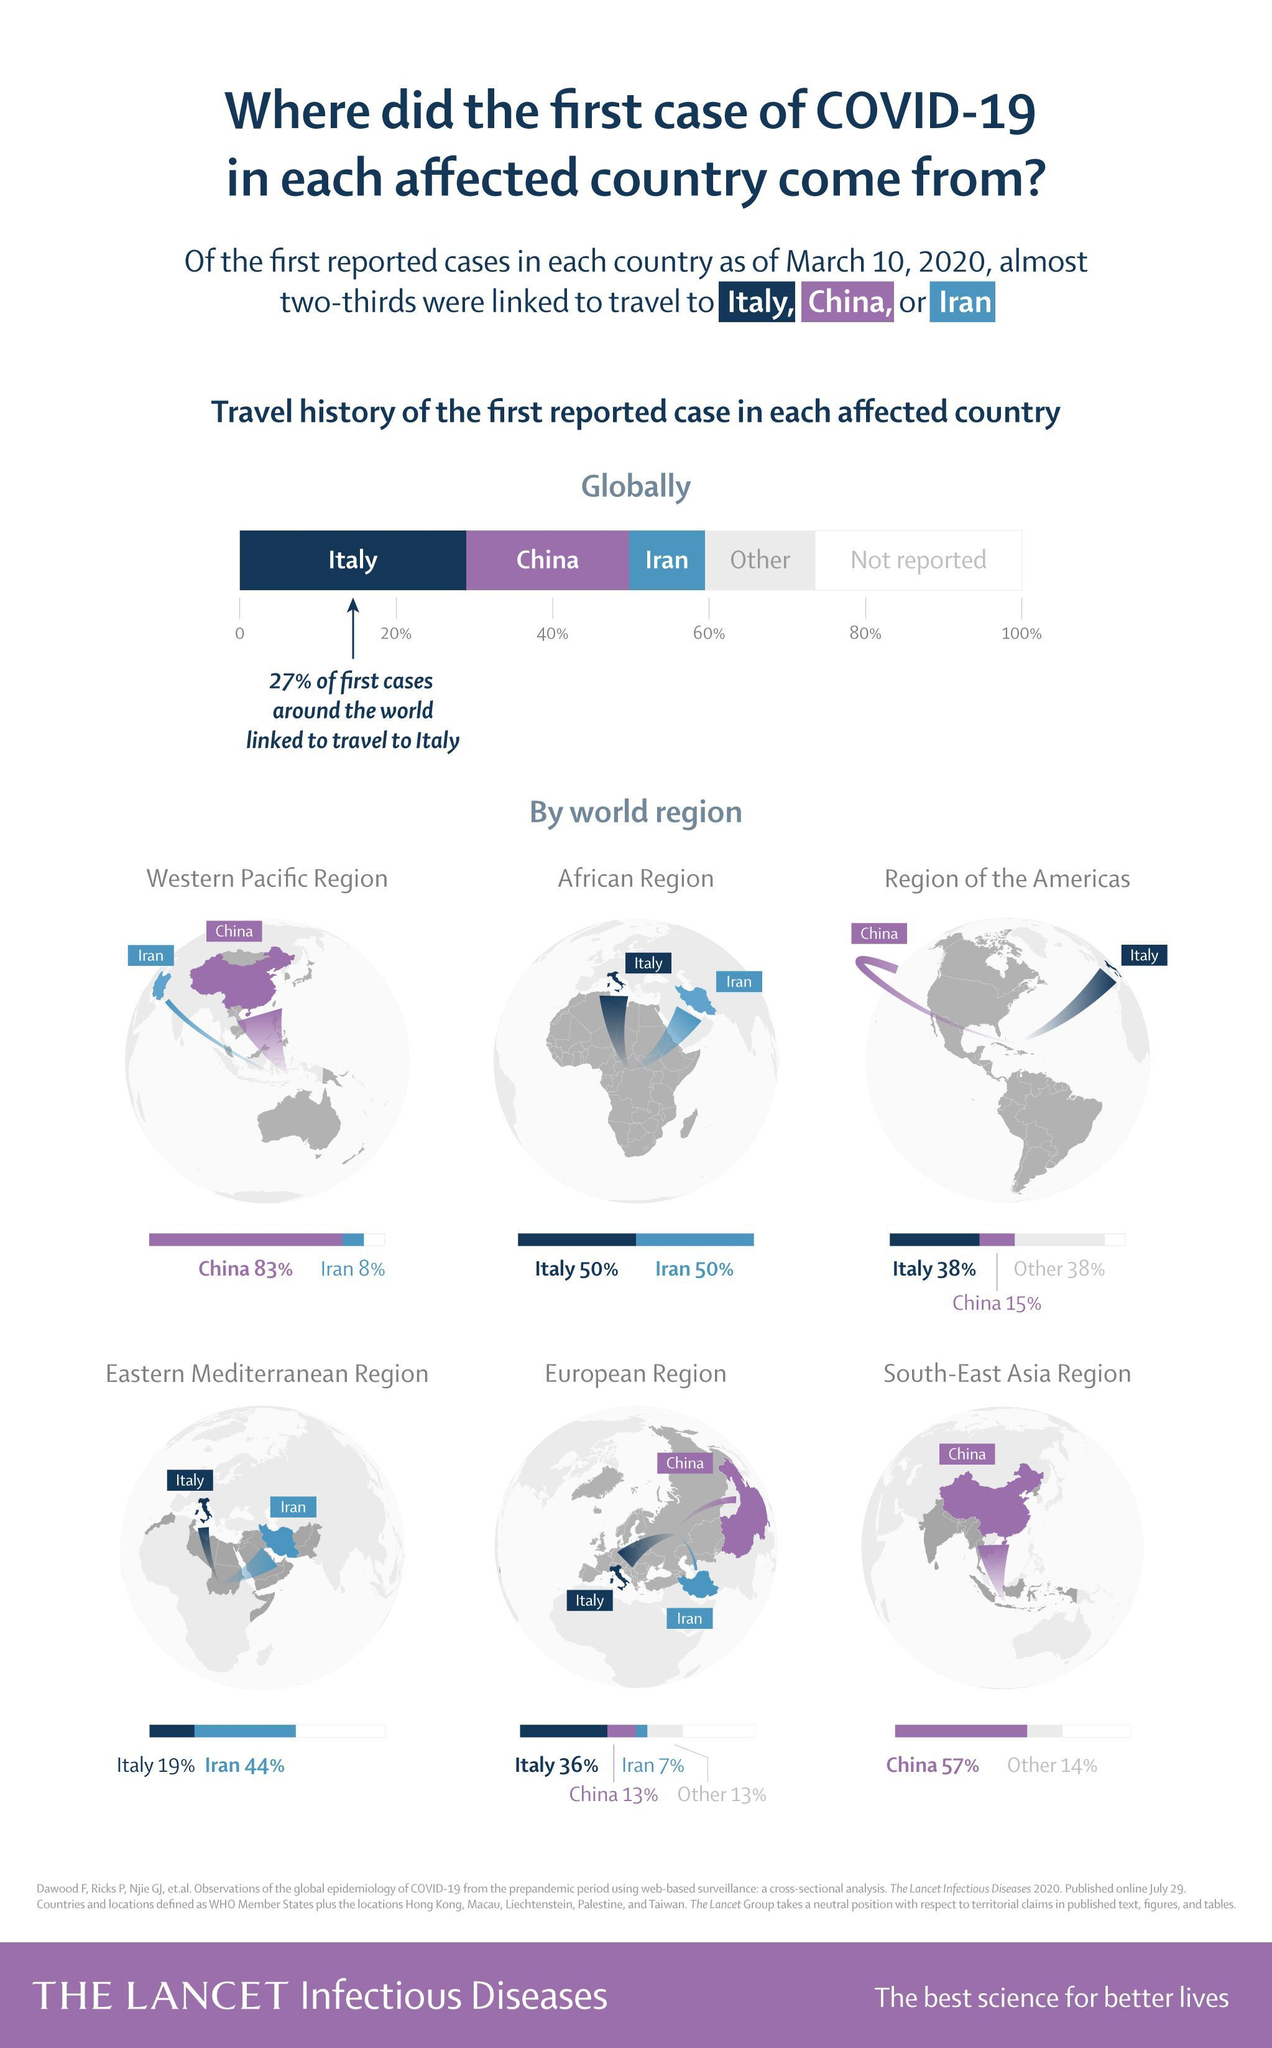What percentage of people in the African region is affected by covid-19 due to traveling to Italy?
Answer the question with a short phrase. 50% What percentage of people are affected by covid-19 due to traveling to Italy? 27% What percentage of people in the western pacific region is affected by covid-19 due to traveling to China? 83% What percentage of people in the European region are affected by covid-19 due to traveling to Iran? 7% 